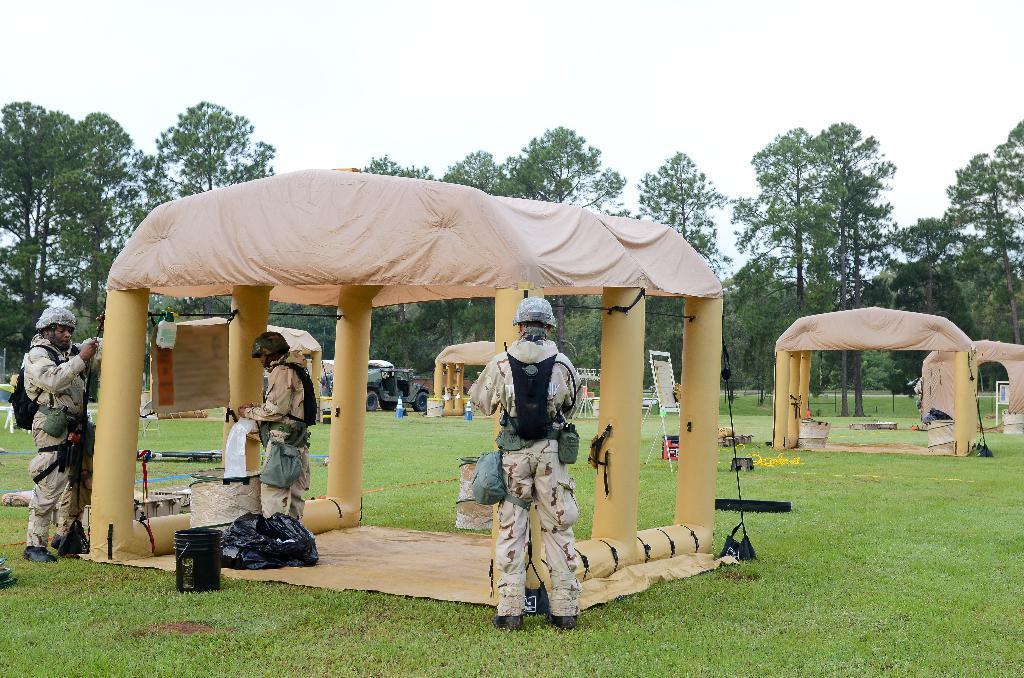How would you summarize this image in a sentence or two? In the image there are three men in camouflage dress standing on either side of tent with bags under it and over the background there are many trees all over the place followed by trees and above its sky. 